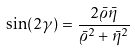<formula> <loc_0><loc_0><loc_500><loc_500>\sin ( 2 \gamma ) = \frac { 2 \bar { \varrho } \bar { \eta } } { \bar { \varrho } ^ { 2 } + \bar { \eta } ^ { 2 } }</formula> 